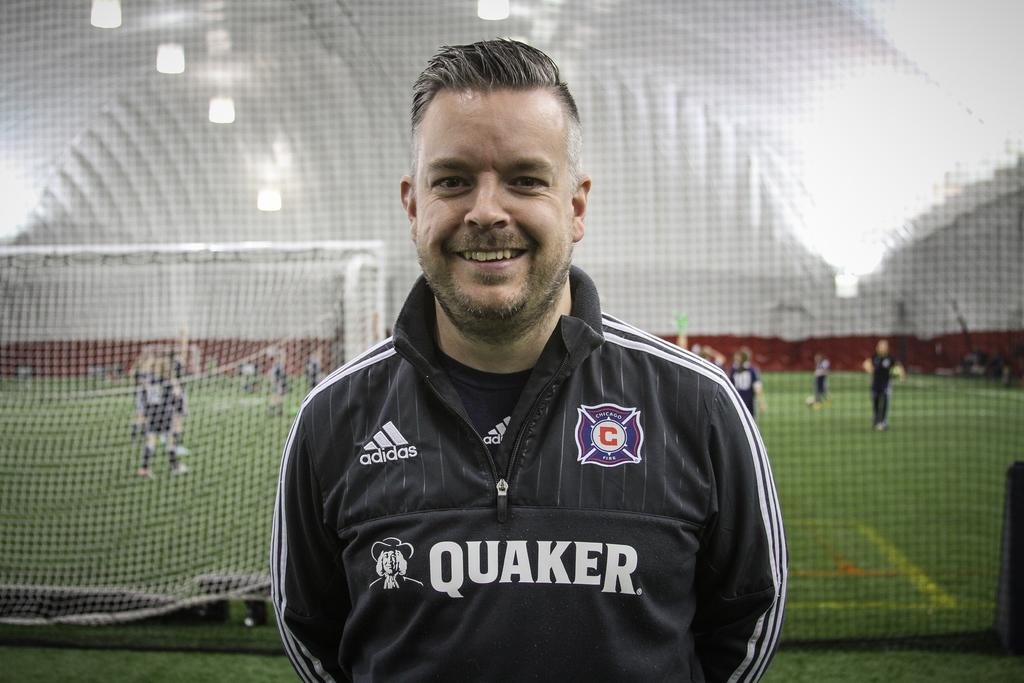<image>
Provide a brief description of the given image. A soccer player is standing by a soccer game and wearing a Quaker sweater. 